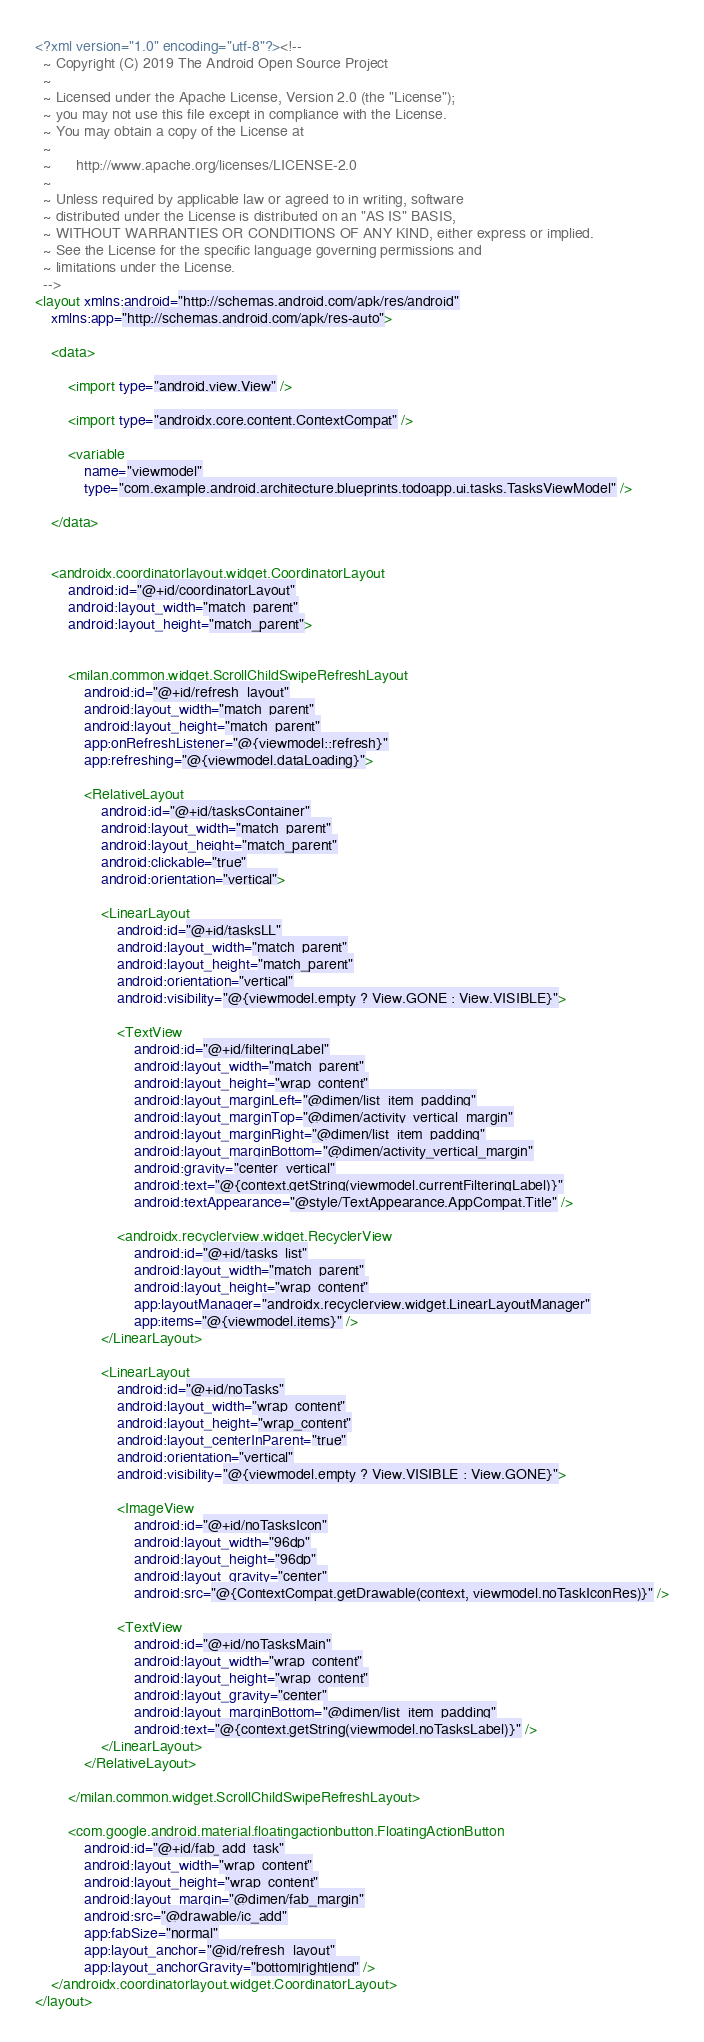<code> <loc_0><loc_0><loc_500><loc_500><_XML_><?xml version="1.0" encoding="utf-8"?><!--
  ~ Copyright (C) 2019 The Android Open Source Project
  ~
  ~ Licensed under the Apache License, Version 2.0 (the "License");
  ~ you may not use this file except in compliance with the License.
  ~ You may obtain a copy of the License at
  ~
  ~      http://www.apache.org/licenses/LICENSE-2.0
  ~
  ~ Unless required by applicable law or agreed to in writing, software
  ~ distributed under the License is distributed on an "AS IS" BASIS,
  ~ WITHOUT WARRANTIES OR CONDITIONS OF ANY KIND, either express or implied.
  ~ See the License for the specific language governing permissions and
  ~ limitations under the License.
  -->
<layout xmlns:android="http://schemas.android.com/apk/res/android"
    xmlns:app="http://schemas.android.com/apk/res-auto">

    <data>

        <import type="android.view.View" />

        <import type="androidx.core.content.ContextCompat" />

        <variable
            name="viewmodel"
            type="com.example.android.architecture.blueprints.todoapp.ui.tasks.TasksViewModel" />

    </data>


    <androidx.coordinatorlayout.widget.CoordinatorLayout
        android:id="@+id/coordinatorLayout"
        android:layout_width="match_parent"
        android:layout_height="match_parent">


        <milan.common.widget.ScrollChildSwipeRefreshLayout
            android:id="@+id/refresh_layout"
            android:layout_width="match_parent"
            android:layout_height="match_parent"
            app:onRefreshListener="@{viewmodel::refresh}"
            app:refreshing="@{viewmodel.dataLoading}">

            <RelativeLayout
                android:id="@+id/tasksContainer"
                android:layout_width="match_parent"
                android:layout_height="match_parent"
                android:clickable="true"
                android:orientation="vertical">

                <LinearLayout
                    android:id="@+id/tasksLL"
                    android:layout_width="match_parent"
                    android:layout_height="match_parent"
                    android:orientation="vertical"
                    android:visibility="@{viewmodel.empty ? View.GONE : View.VISIBLE}">

                    <TextView
                        android:id="@+id/filteringLabel"
                        android:layout_width="match_parent"
                        android:layout_height="wrap_content"
                        android:layout_marginLeft="@dimen/list_item_padding"
                        android:layout_marginTop="@dimen/activity_vertical_margin"
                        android:layout_marginRight="@dimen/list_item_padding"
                        android:layout_marginBottom="@dimen/activity_vertical_margin"
                        android:gravity="center_vertical"
                        android:text="@{context.getString(viewmodel.currentFilteringLabel)}"
                        android:textAppearance="@style/TextAppearance.AppCompat.Title" />

                    <androidx.recyclerview.widget.RecyclerView
                        android:id="@+id/tasks_list"
                        android:layout_width="match_parent"
                        android:layout_height="wrap_content"
                        app:layoutManager="androidx.recyclerview.widget.LinearLayoutManager"
                        app:items="@{viewmodel.items}" />
                </LinearLayout>

                <LinearLayout
                    android:id="@+id/noTasks"
                    android:layout_width="wrap_content"
                    android:layout_height="wrap_content"
                    android:layout_centerInParent="true"
                    android:orientation="vertical"
                    android:visibility="@{viewmodel.empty ? View.VISIBLE : View.GONE}">

                    <ImageView
                        android:id="@+id/noTasksIcon"
                        android:layout_width="96dp"
                        android:layout_height="96dp"
                        android:layout_gravity="center"
                        android:src="@{ContextCompat.getDrawable(context, viewmodel.noTaskIconRes)}" />

                    <TextView
                        android:id="@+id/noTasksMain"
                        android:layout_width="wrap_content"
                        android:layout_height="wrap_content"
                        android:layout_gravity="center"
                        android:layout_marginBottom="@dimen/list_item_padding"
                        android:text="@{context.getString(viewmodel.noTasksLabel)}" />
                </LinearLayout>
            </RelativeLayout>

        </milan.common.widget.ScrollChildSwipeRefreshLayout>

        <com.google.android.material.floatingactionbutton.FloatingActionButton
            android:id="@+id/fab_add_task"
            android:layout_width="wrap_content"
            android:layout_height="wrap_content"
            android:layout_margin="@dimen/fab_margin"
            android:src="@drawable/ic_add"
            app:fabSize="normal"
            app:layout_anchor="@id/refresh_layout"
            app:layout_anchorGravity="bottom|right|end" />
    </androidx.coordinatorlayout.widget.CoordinatorLayout>
</layout>

</code> 